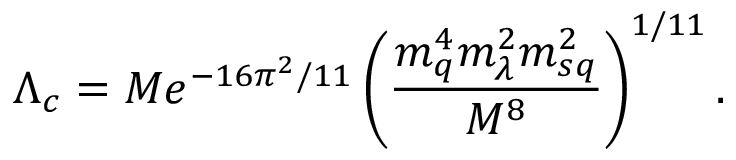<formula> <loc_0><loc_0><loc_500><loc_500>\Lambda _ { c } = M e ^ { - 1 6 \pi ^ { 2 } / 1 1 } \left ( \frac { m _ { q } ^ { 4 } m _ { \lambda } ^ { 2 } m _ { s q } ^ { 2 } } { M ^ { 8 } } \right ) ^ { 1 / 1 1 } .</formula> 